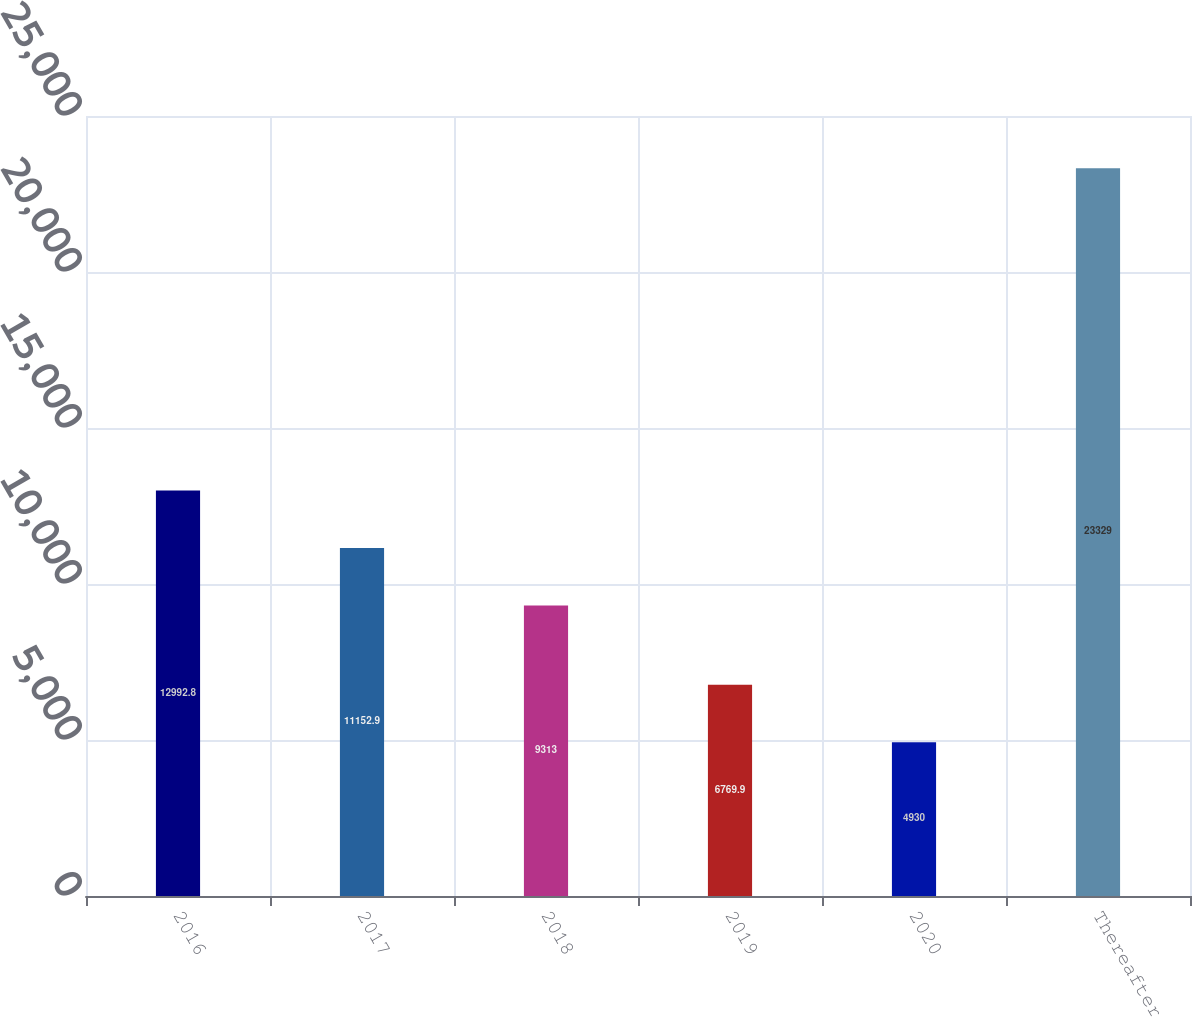Convert chart to OTSL. <chart><loc_0><loc_0><loc_500><loc_500><bar_chart><fcel>2016<fcel>2017<fcel>2018<fcel>2019<fcel>2020<fcel>Thereafter<nl><fcel>12992.8<fcel>11152.9<fcel>9313<fcel>6769.9<fcel>4930<fcel>23329<nl></chart> 